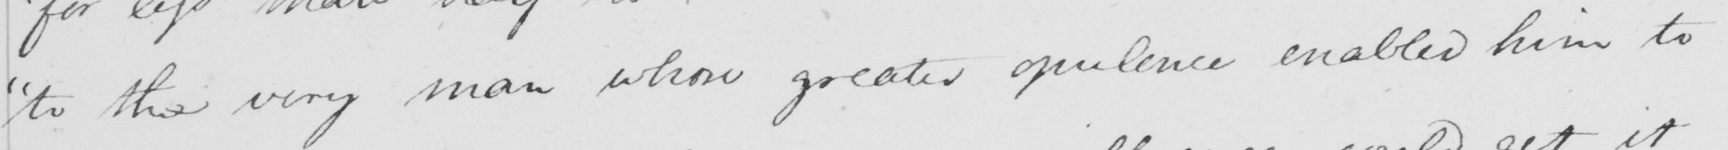Can you read and transcribe this handwriting? " to the very man whose greater opulence enabled him to 